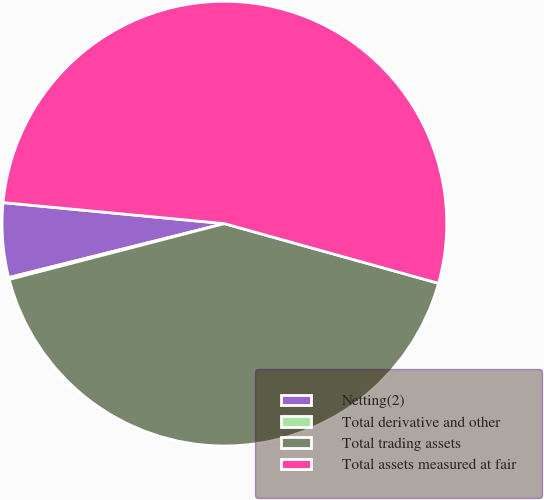Convert chart to OTSL. <chart><loc_0><loc_0><loc_500><loc_500><pie_chart><fcel>Netting(2)<fcel>Total derivative and other<fcel>Total trading assets<fcel>Total assets measured at fair<nl><fcel>5.41%<fcel>0.14%<fcel>41.63%<fcel>52.81%<nl></chart> 